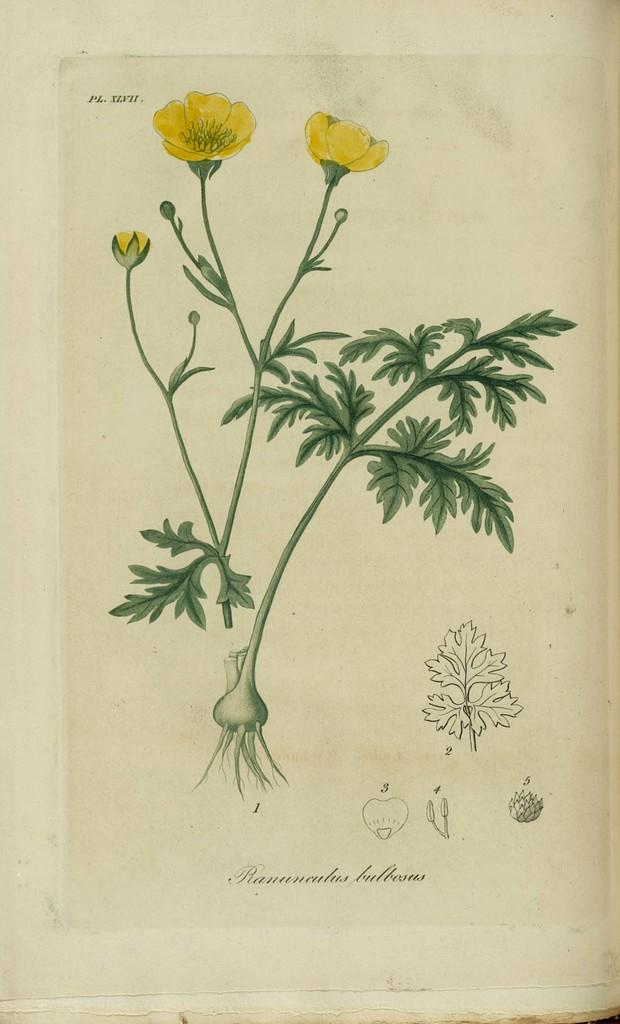What is the main subject of the image? The image contains a painting. What is the painting depicting? The painting depicts different types of plants. What material is the painting on? The painting is on paper. What type of quince is featured in the painting? There is no quince present in the painting; it depicts different types of plants. Can you see any ghosts interacting with the plants in the painting? There are no ghosts present in the painting; it only depicts plants on paper. 